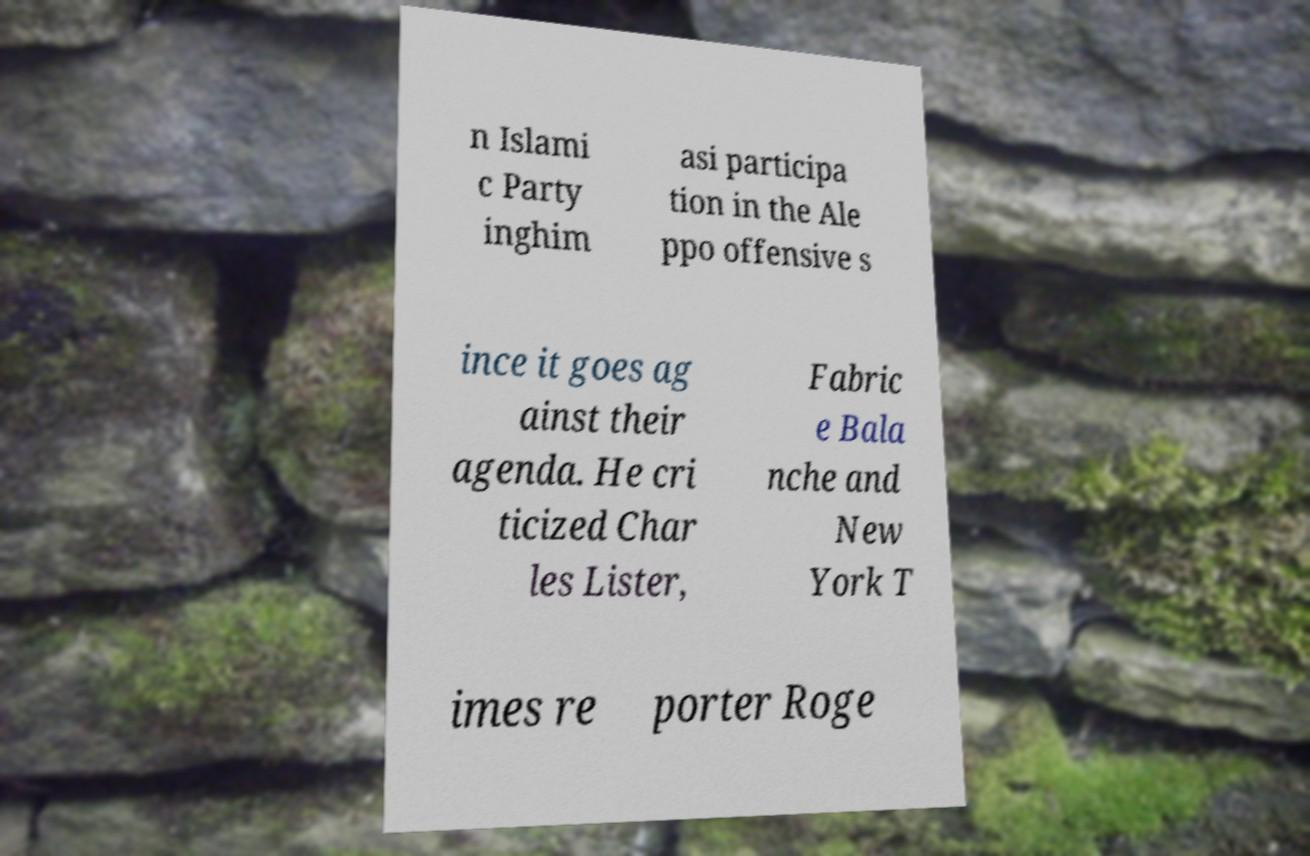Please read and relay the text visible in this image. What does it say? n Islami c Party inghim asi participa tion in the Ale ppo offensive s ince it goes ag ainst their agenda. He cri ticized Char les Lister, Fabric e Bala nche and New York T imes re porter Roge 